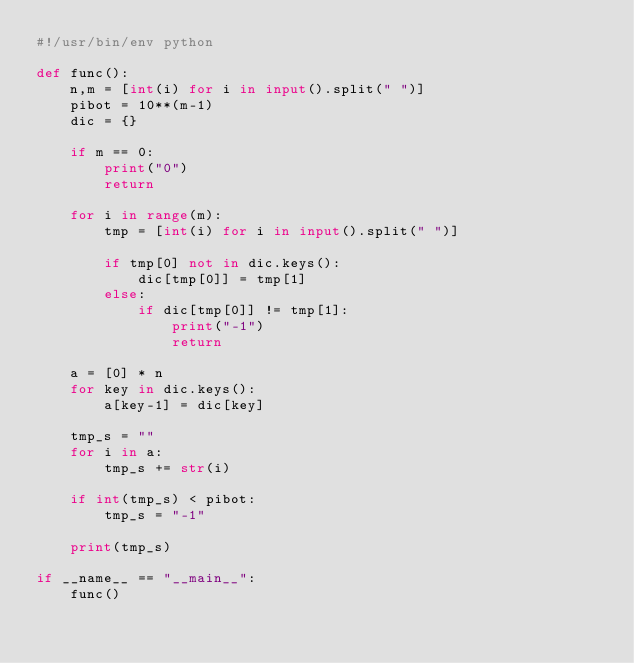<code> <loc_0><loc_0><loc_500><loc_500><_Python_>#!/usr/bin/env python

def func():
    n,m = [int(i) for i in input().split(" ")]
    pibot = 10**(m-1)
    dic = {}

    if m == 0:
        print("0")
        return

    for i in range(m):
        tmp = [int(i) for i in input().split(" ")]

        if tmp[0] not in dic.keys():
            dic[tmp[0]] = tmp[1]
        else:
            if dic[tmp[0]] != tmp[1]:
                print("-1")
                return

    a = [0] * n
    for key in dic.keys():
        a[key-1] = dic[key]

    tmp_s = ""
    for i in a:
        tmp_s += str(i)

    if int(tmp_s) < pibot:
        tmp_s = "-1"

    print(tmp_s)

if __name__ == "__main__":
    func()</code> 